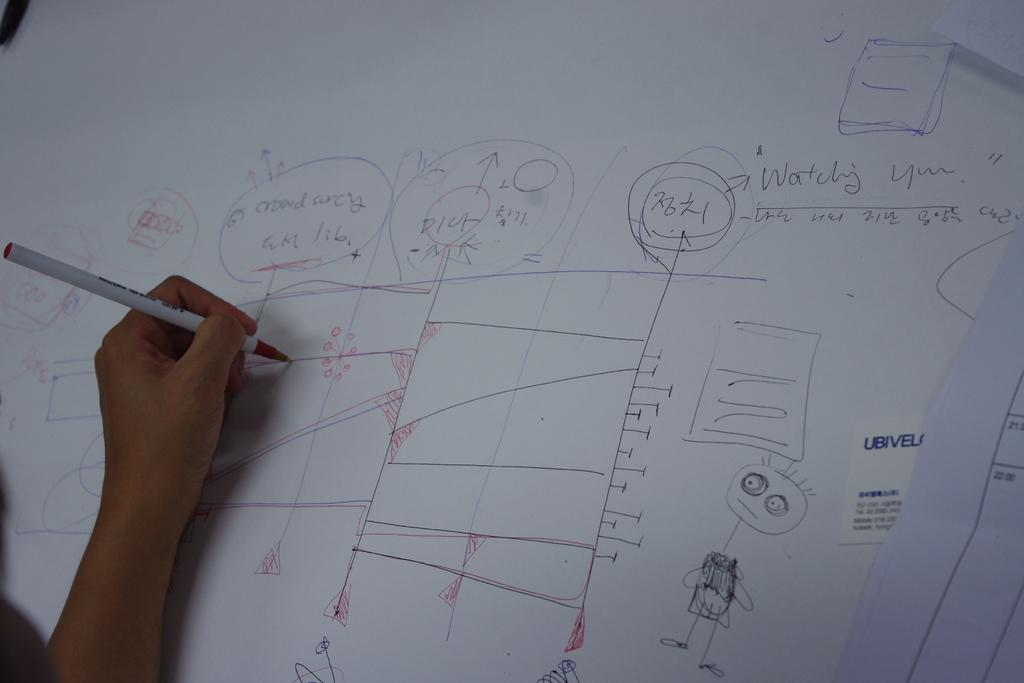Provide a one-sentence caption for the provided image. a white board with the words Watching You on it. 